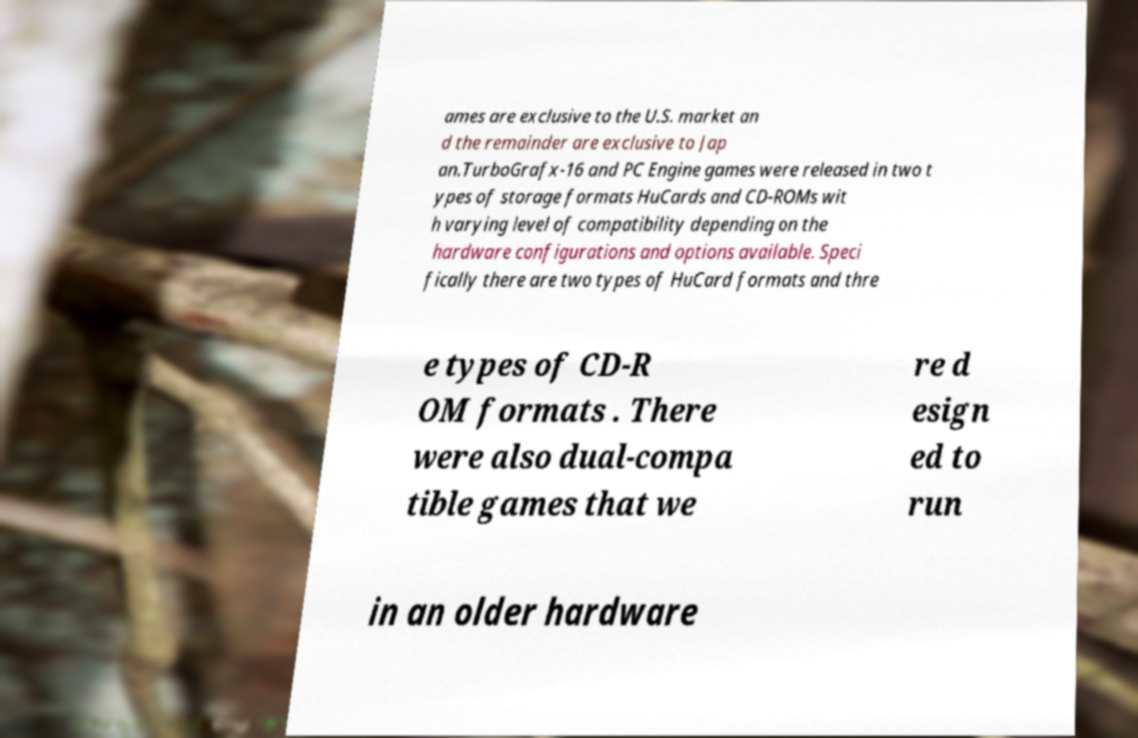Could you assist in decoding the text presented in this image and type it out clearly? ames are exclusive to the U.S. market an d the remainder are exclusive to Jap an.TurboGrafx-16 and PC Engine games were released in two t ypes of storage formats HuCards and CD-ROMs wit h varying level of compatibility depending on the hardware configurations and options available. Speci fically there are two types of HuCard formats and thre e types of CD-R OM formats . There were also dual-compa tible games that we re d esign ed to run in an older hardware 